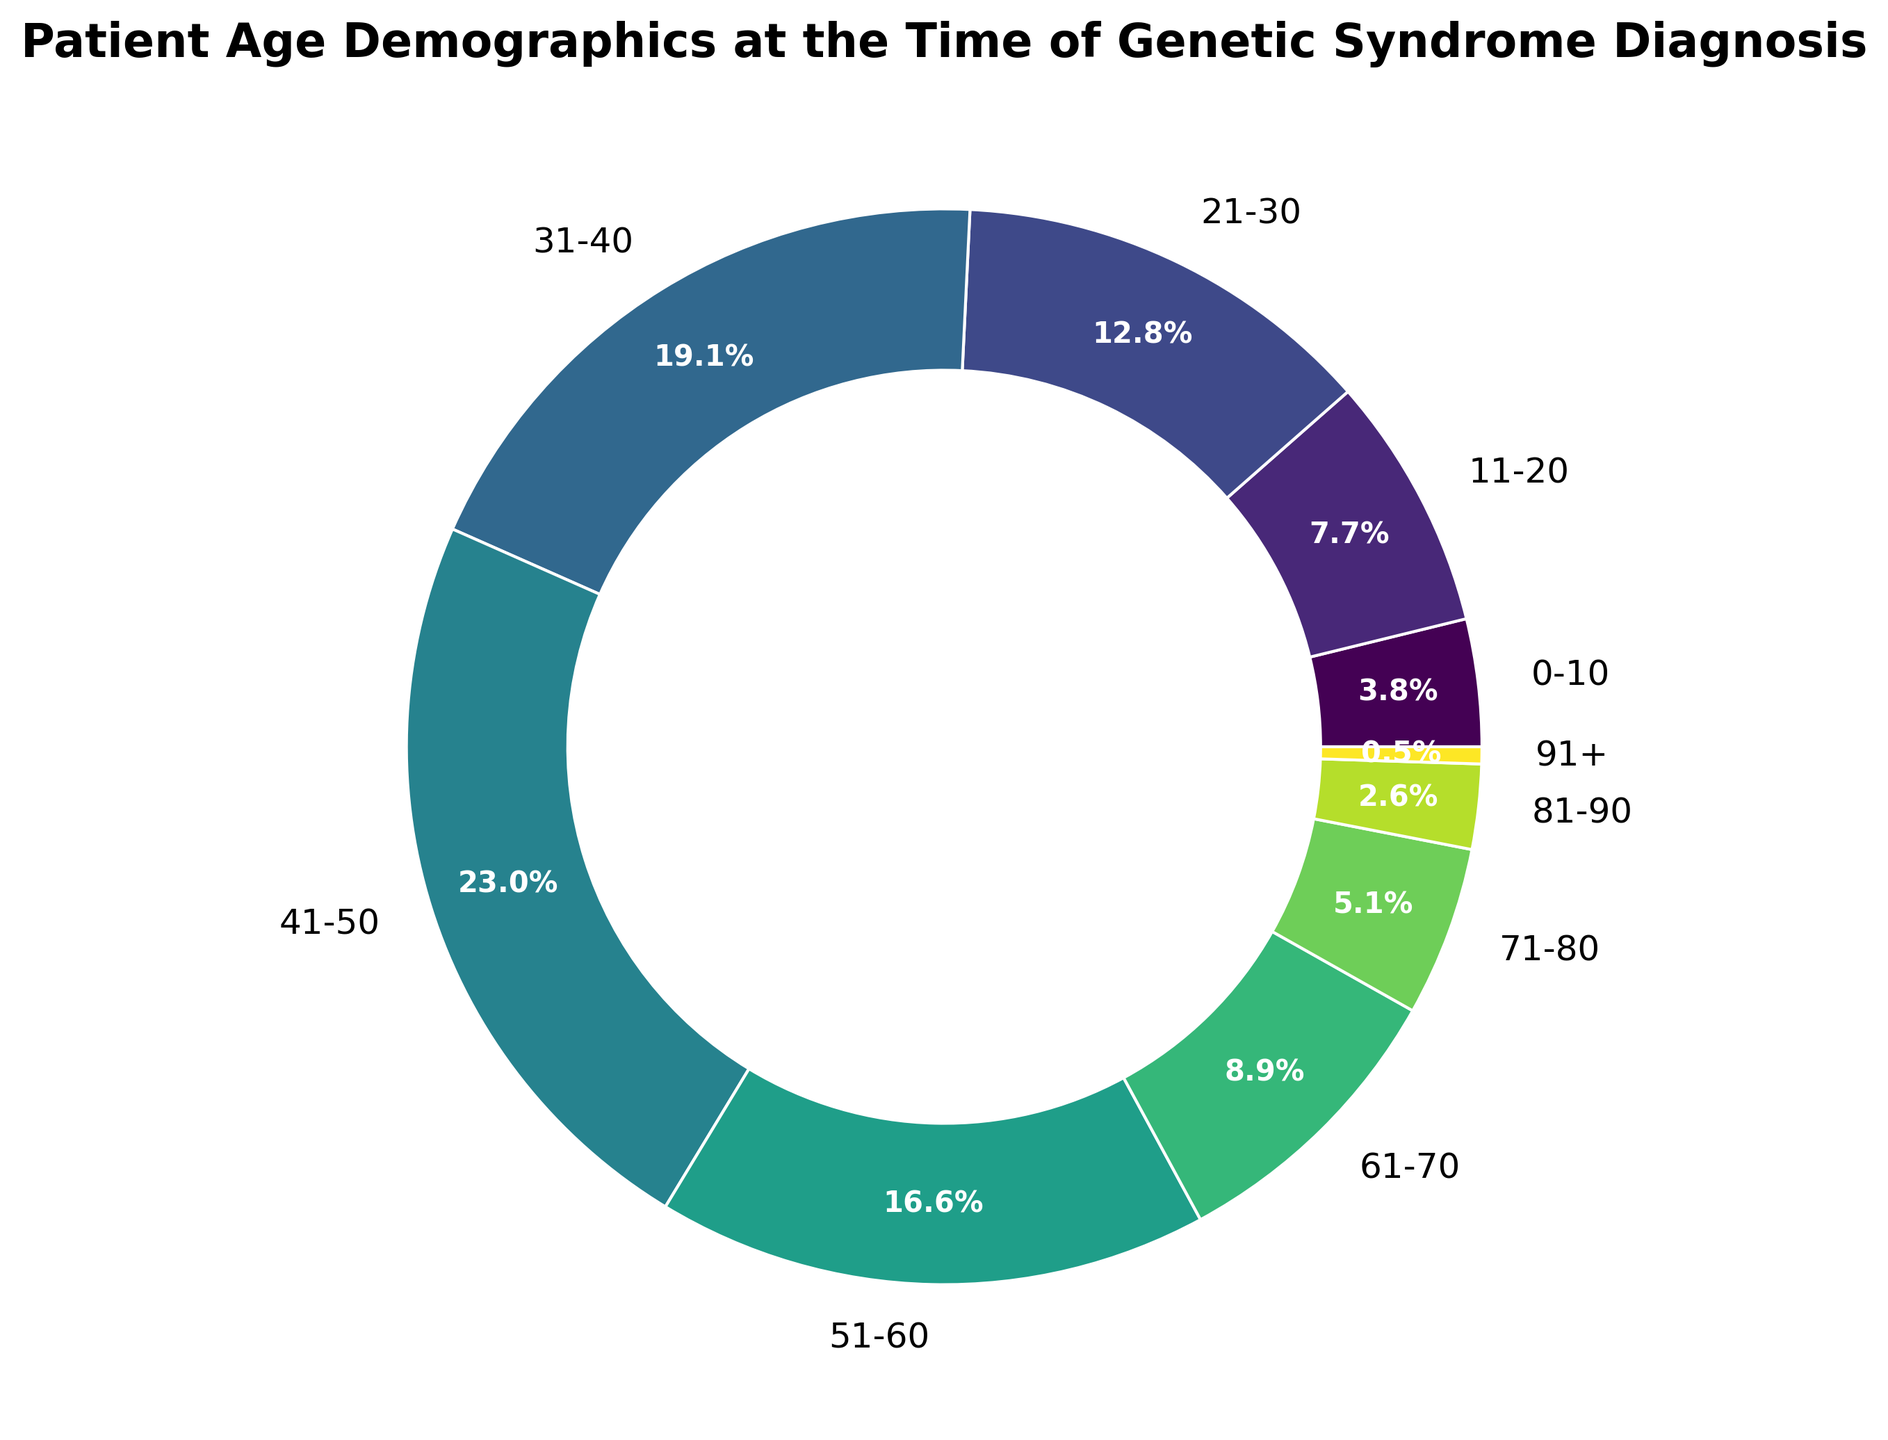What is the age range with the highest number of patients? Look at the age range segment that occupies the largest portion of the ring chart. The 41-50 age range is the largest segment.
Answer: 41-50 Which age range has the least number of patients? Identify the smallest segment in the ring chart. The segment for the 91+ age range is the smallest.
Answer: 91+ How many patients are younger than 21 at the time of diagnosis? Sum the number of patients in the 0-10 and 11-20 age ranges by adding 15 and 30.
Answer: 45 Are there more patients diagnosed between ages 21-30 or 61-70? Compare the sizes of the segments for the 21-30 and 61-70 age ranges. The 21-30 age range has 50 patients and the 61-70 age range has 35 patients.
Answer: 21-30 What percentage of patients are older than 60 at the time of diagnosis? Sum the number of patients in the 61-70, 71-80, 81-90, and 91+ age ranges and then divide by the total number of patients. (35+20+10+2=67) and (67/392*100).
Answer: 17.1% Which age range has 75 patients diagnosed with a genetic syndrome? Look at the segment labeled with "75." This is the 31-40 age range segment.
Answer: 31-40 How many patients are aged between 31 and 60? Add the number of patients in the 31-40, 41-50, and 51-60 age ranges by summing 75, 90, and 65.
Answer: 230 Is the number of patients in the 51-60 age range greater than that in the 0-10 and 11-20 age ranges combined? Add the number of patients in the 0-10 and 11-20 age ranges, then compare with the number in the 51-60 age range. (15+30=45) and (65 > 45).
Answer: Yes What percent of patients were diagnosed between ages 41 and 50? Locate the segment for the 41-50 age range and read the percentage label.
Answer: 23.0% 